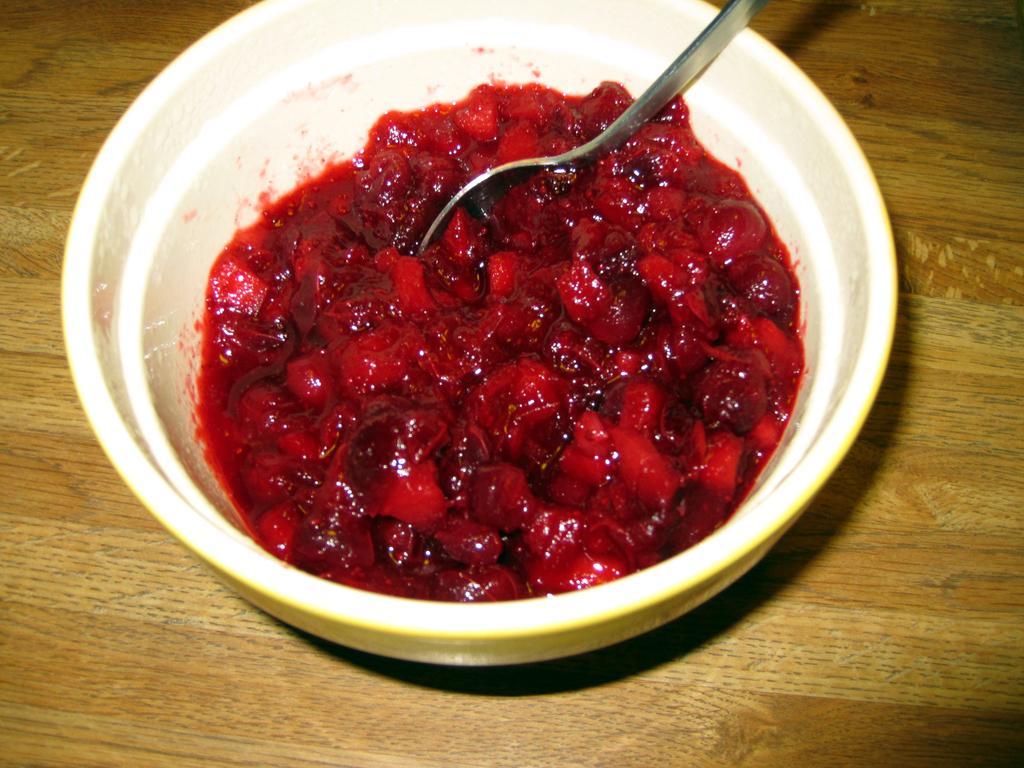Can you describe this image briefly? In this image we can see there is a table. On the table there is a food item and spoon in the bowl. 